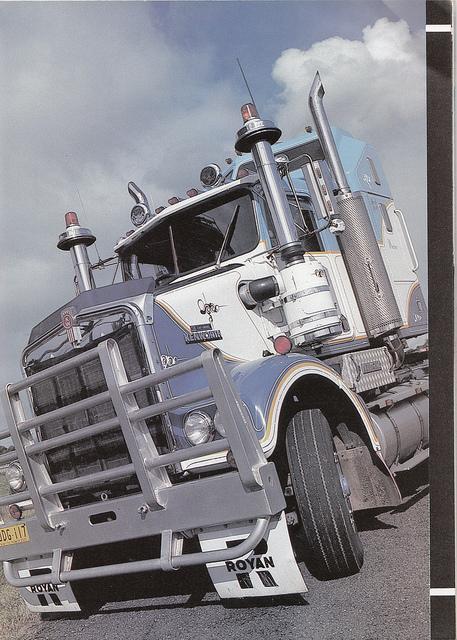Is this a pickup truck?
Quick response, please. No. How many exhaust pipes does the truck have?
Be succinct. 2. Can this truck haul things?
Quick response, please. Yes. 